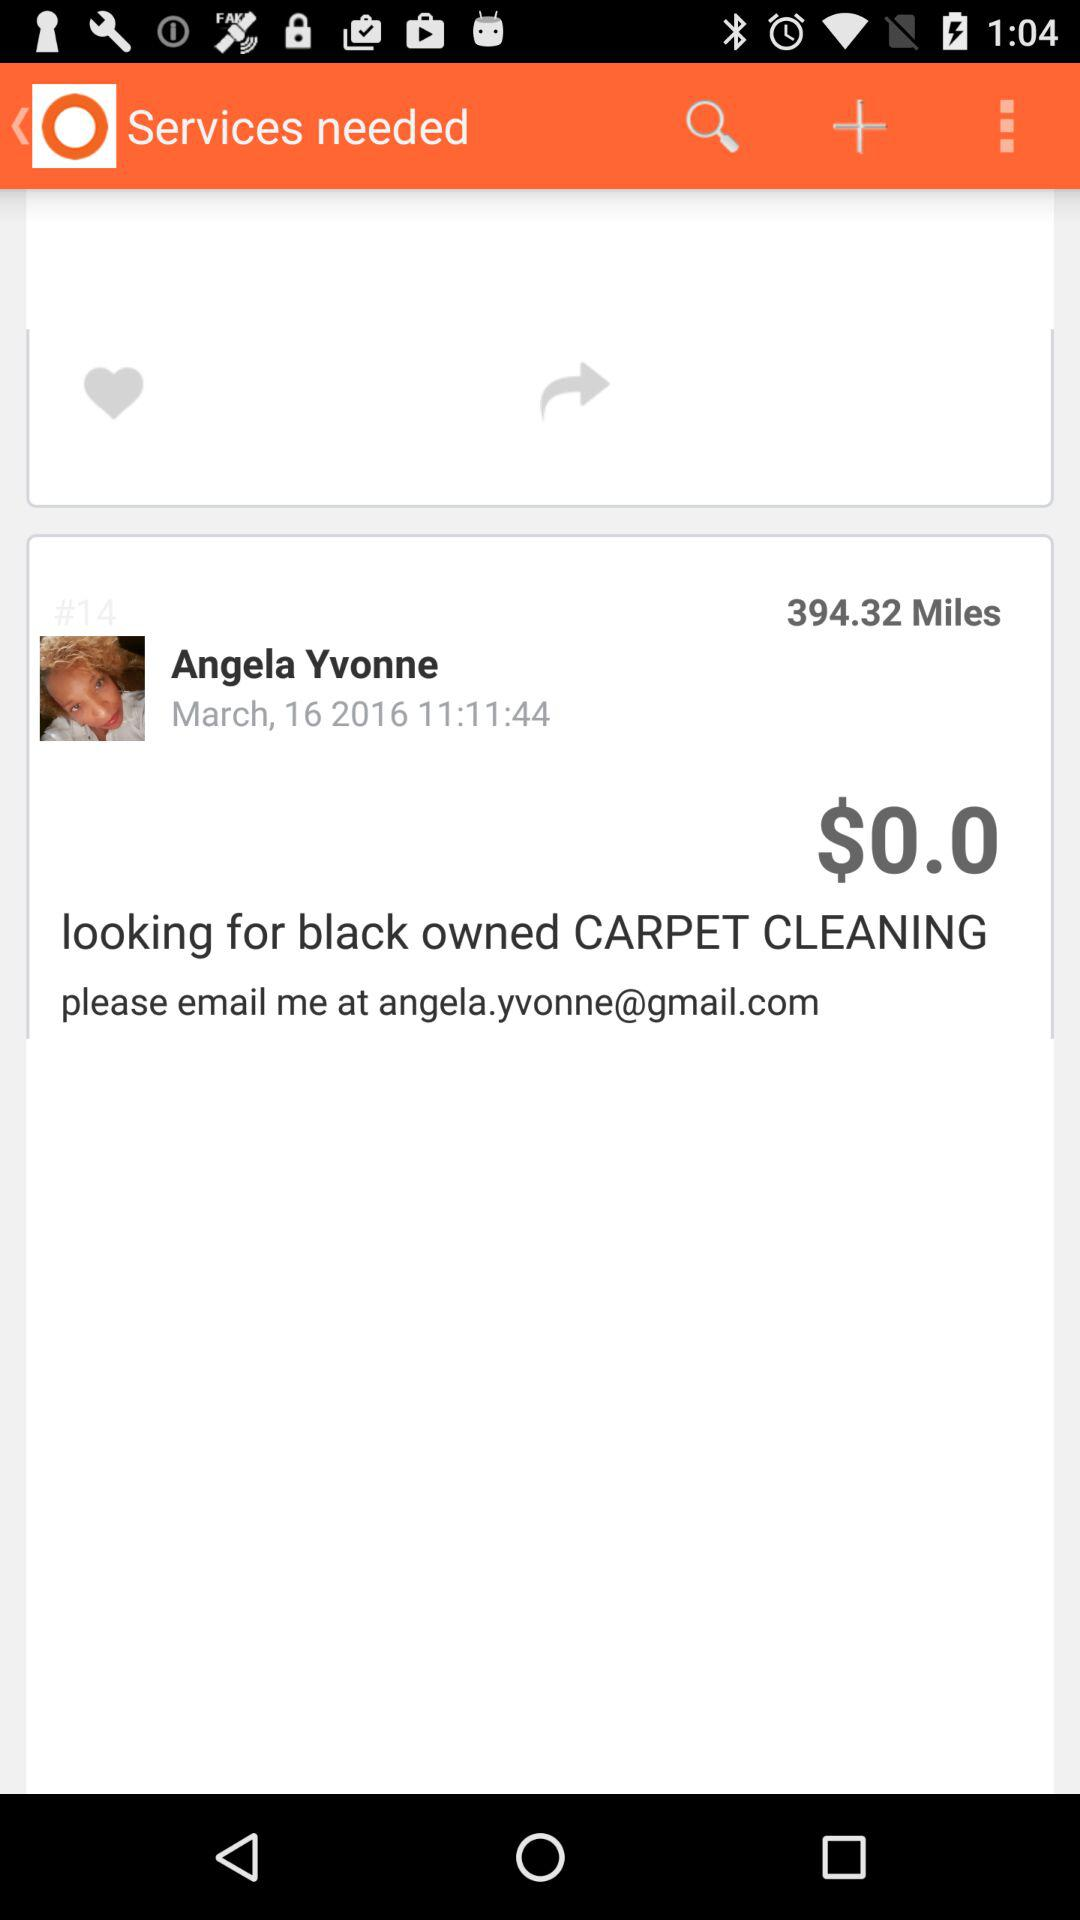How much is the distance? The distance is 394.32 miles. 